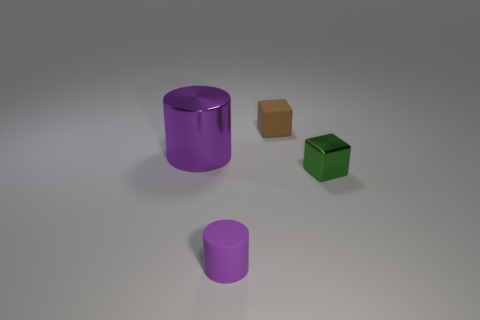Add 2 tiny brown things. How many objects exist? 6 Subtract 2 blocks. How many blocks are left? 0 Add 2 tiny brown cubes. How many tiny brown cubes are left? 3 Add 4 purple things. How many purple things exist? 6 Subtract 0 red cubes. How many objects are left? 4 Subtract all yellow cylinders. Subtract all red cubes. How many cylinders are left? 2 Subtract all big cyan metal spheres. Subtract all cubes. How many objects are left? 2 